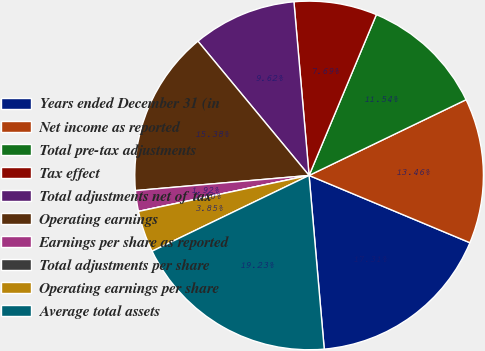<chart> <loc_0><loc_0><loc_500><loc_500><pie_chart><fcel>Years ended December 31 (in<fcel>Net income as reported<fcel>Total pre-tax adjustments<fcel>Tax effect<fcel>Total adjustments net of tax<fcel>Operating earnings<fcel>Earnings per share as reported<fcel>Total adjustments per share<fcel>Operating earnings per share<fcel>Average total assets<nl><fcel>17.31%<fcel>13.46%<fcel>11.54%<fcel>7.69%<fcel>9.62%<fcel>15.38%<fcel>1.92%<fcel>0.0%<fcel>3.85%<fcel>19.23%<nl></chart> 